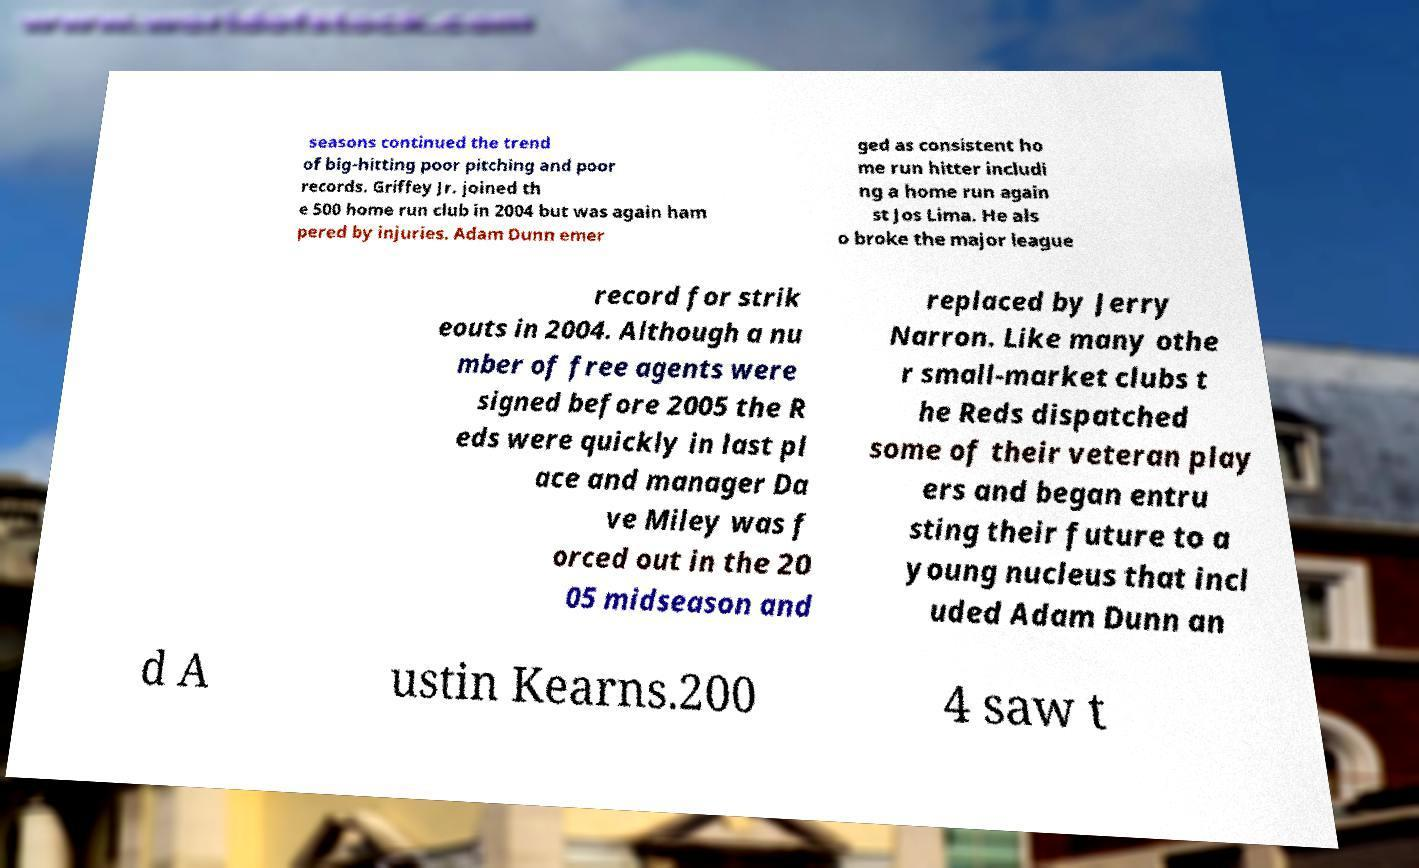I need the written content from this picture converted into text. Can you do that? seasons continued the trend of big-hitting poor pitching and poor records. Griffey Jr. joined th e 500 home run club in 2004 but was again ham pered by injuries. Adam Dunn emer ged as consistent ho me run hitter includi ng a home run again st Jos Lima. He als o broke the major league record for strik eouts in 2004. Although a nu mber of free agents were signed before 2005 the R eds were quickly in last pl ace and manager Da ve Miley was f orced out in the 20 05 midseason and replaced by Jerry Narron. Like many othe r small-market clubs t he Reds dispatched some of their veteran play ers and began entru sting their future to a young nucleus that incl uded Adam Dunn an d A ustin Kearns.200 4 saw t 